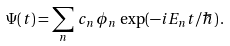Convert formula to latex. <formula><loc_0><loc_0><loc_500><loc_500>\Psi ( t ) = \sum _ { n } \, c _ { n } \, \phi _ { n } \, \exp ( - i E _ { n } t / \hbar { ) } \, .</formula> 